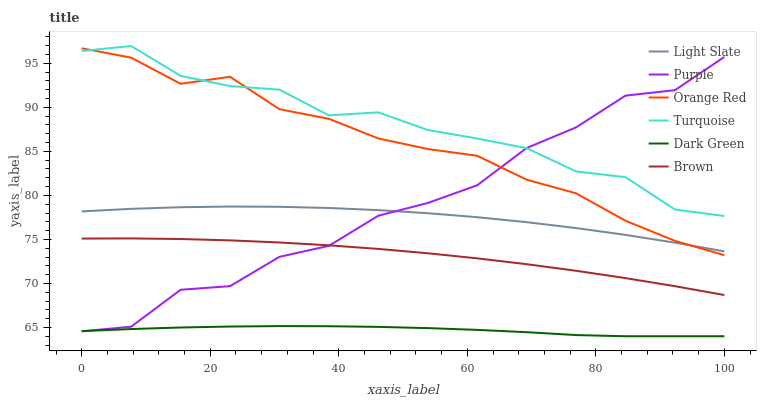Does Dark Green have the minimum area under the curve?
Answer yes or no. Yes. Does Turquoise have the maximum area under the curve?
Answer yes or no. Yes. Does Light Slate have the minimum area under the curve?
Answer yes or no. No. Does Light Slate have the maximum area under the curve?
Answer yes or no. No. Is Dark Green the smoothest?
Answer yes or no. Yes. Is Purple the roughest?
Answer yes or no. Yes. Is Turquoise the smoothest?
Answer yes or no. No. Is Turquoise the roughest?
Answer yes or no. No. Does Light Slate have the lowest value?
Answer yes or no. No. Does Turquoise have the highest value?
Answer yes or no. Yes. Does Light Slate have the highest value?
Answer yes or no. No. Is Brown less than Orange Red?
Answer yes or no. Yes. Is Orange Red greater than Brown?
Answer yes or no. Yes. Does Purple intersect Orange Red?
Answer yes or no. Yes. Is Purple less than Orange Red?
Answer yes or no. No. Is Purple greater than Orange Red?
Answer yes or no. No. Does Brown intersect Orange Red?
Answer yes or no. No. 